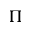Convert formula to latex. <formula><loc_0><loc_0><loc_500><loc_500>\Pi</formula> 